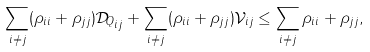<formula> <loc_0><loc_0><loc_500><loc_500>\sum _ { i \ne j } ( \rho _ { i i } + \rho _ { j j } ) { \mathcal { D } _ { Q } } _ { i j } + \sum _ { i \ne j } ( \rho _ { i i } + \rho _ { j j } ) \mathcal { V } _ { i j } \leq \sum _ { i \ne j } \rho _ { i i } + \rho _ { j j } ,</formula> 